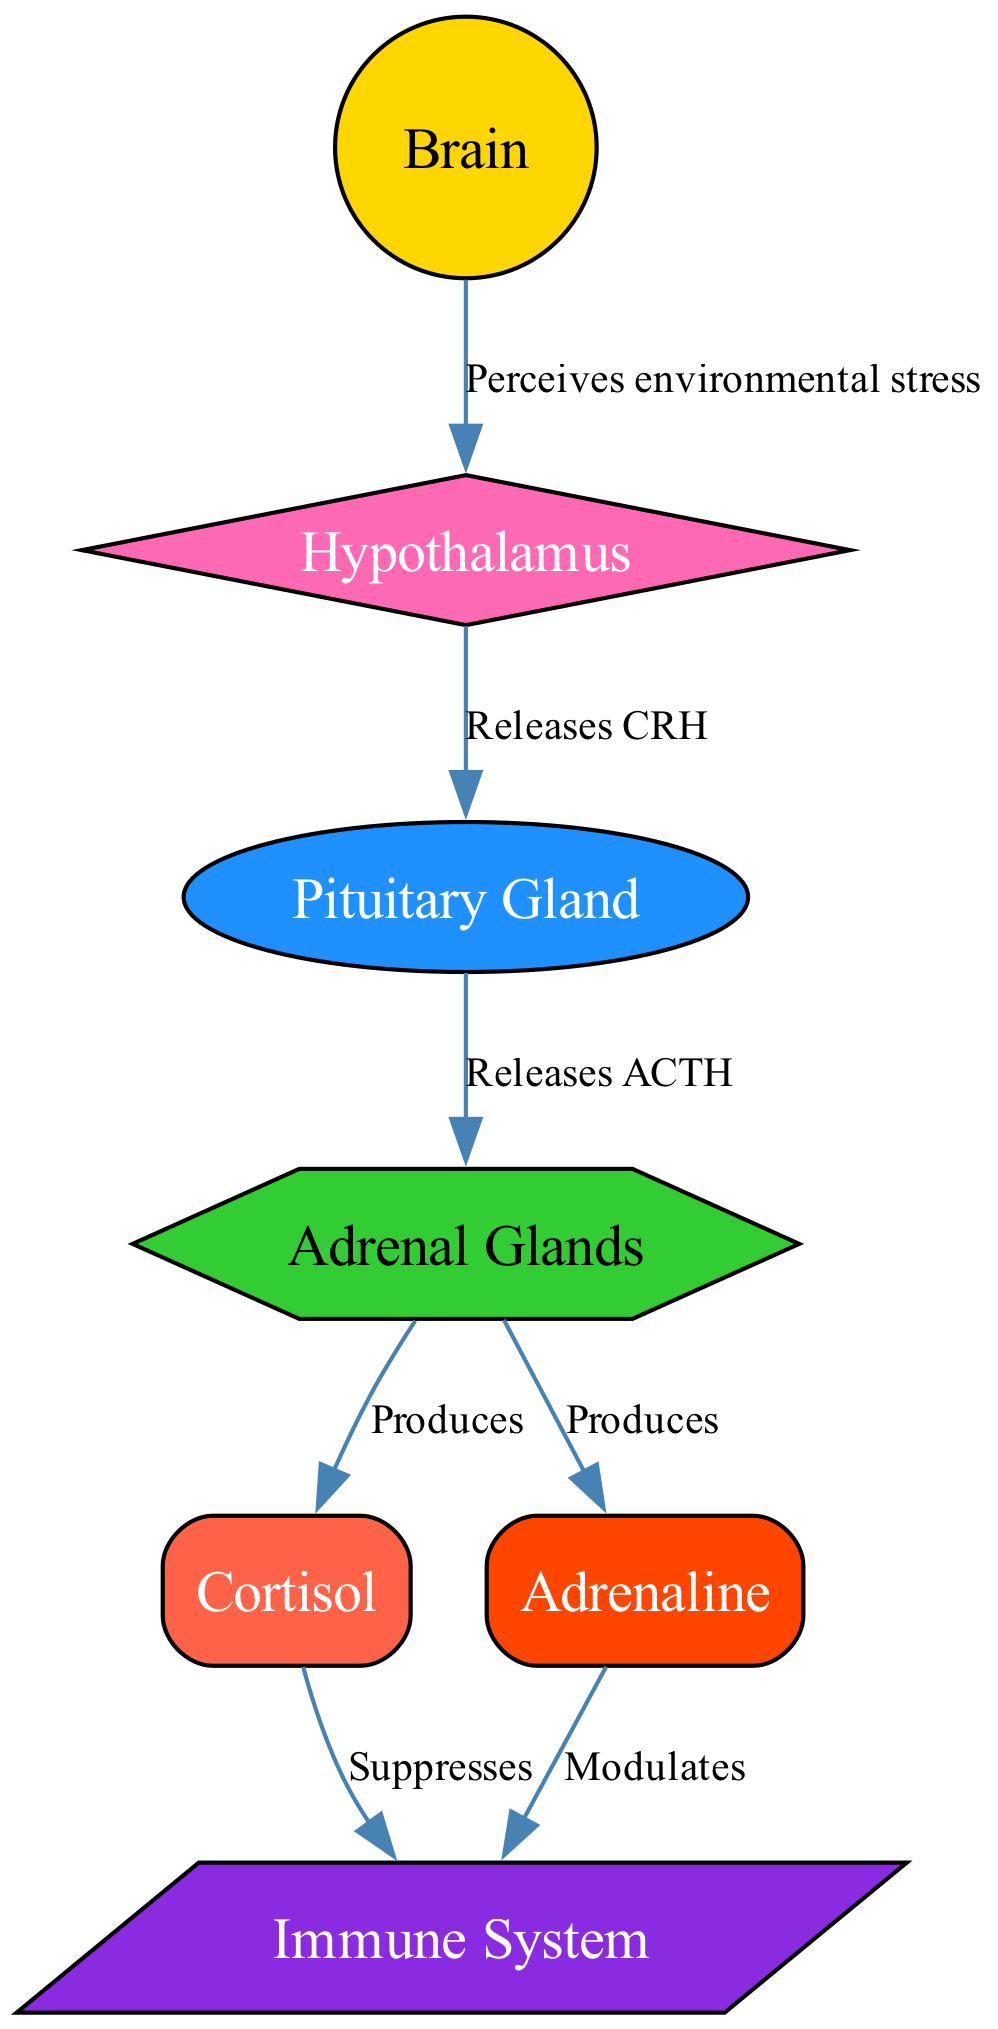What is the primary source of cortisol in the diagram? The adrenal glands are indicated as the source of cortisol production. This is determined by tracing the flow from the adrenal node to the cortisol node, which is connected with a label stating "Produces."
Answer: Adrenal Glands How many nodes are present in the diagram? By counting each unique entity represented in the diagram, we find there are seven nodes labeled as: Brain, Hypothalamus, Pituitary Gland, Adrenal Glands, Cortisol, Adrenaline, and Immune System.
Answer: Seven Which hormone is indicated as modulating the immune system? The diagram shows that adrenaline has an edge leading to the immune system with the label "Modulates." This clearly identifies adrenaline as the hormone responsible for this action.
Answer: Adrenaline What does the hypothalamus release in response to environmental stress? The diagram connects the hypothalamus to the pituitary gland with an edge labeled "Releases CRH," indicating that the hypothalamus secretes Corticotropin-Releasing Hormone (CRH) during stress.
Answer: CRH How does cortisol affect the immune system according to the diagram? Cortisol is shown to have an edge pointing towards the immune system labeled "Suppresses," which indicates its negative effect on immune function. By following the connections, we establish that cortisol decreases immune activity.
Answer: Suppresses What is the role of the pituitary gland in hormonal changes? The pituitary gland receives hormone signals from the hypothalamus (specifically CRH) and responds by releasing Adrenocorticotropic Hormone (ACTH), which acts on the adrenal glands to produce cortisol and adrenaline. This indicates its central regulatory role in triggering the stress response.
Answer: Releases ACTH How are the immune system and cortisol connected in the diagram? The diagram shows that cortisol suppresses the immune system, as evidenced by the directed edge from the cortisol node to the immune node, labeled "Suppresses." This indicates that increased cortisol levels negatively impact immune response.
Answer: Suppresses Which gland is responsible for producing both cortisol and adrenaline? The adrenal glands are pointed out in the diagram with edges showing they produce both cortisol and adrenaline. Each production pathway is labeled as "Produces," directly linking the adrenal glands to both hormones.
Answer: Adrenal Glands 